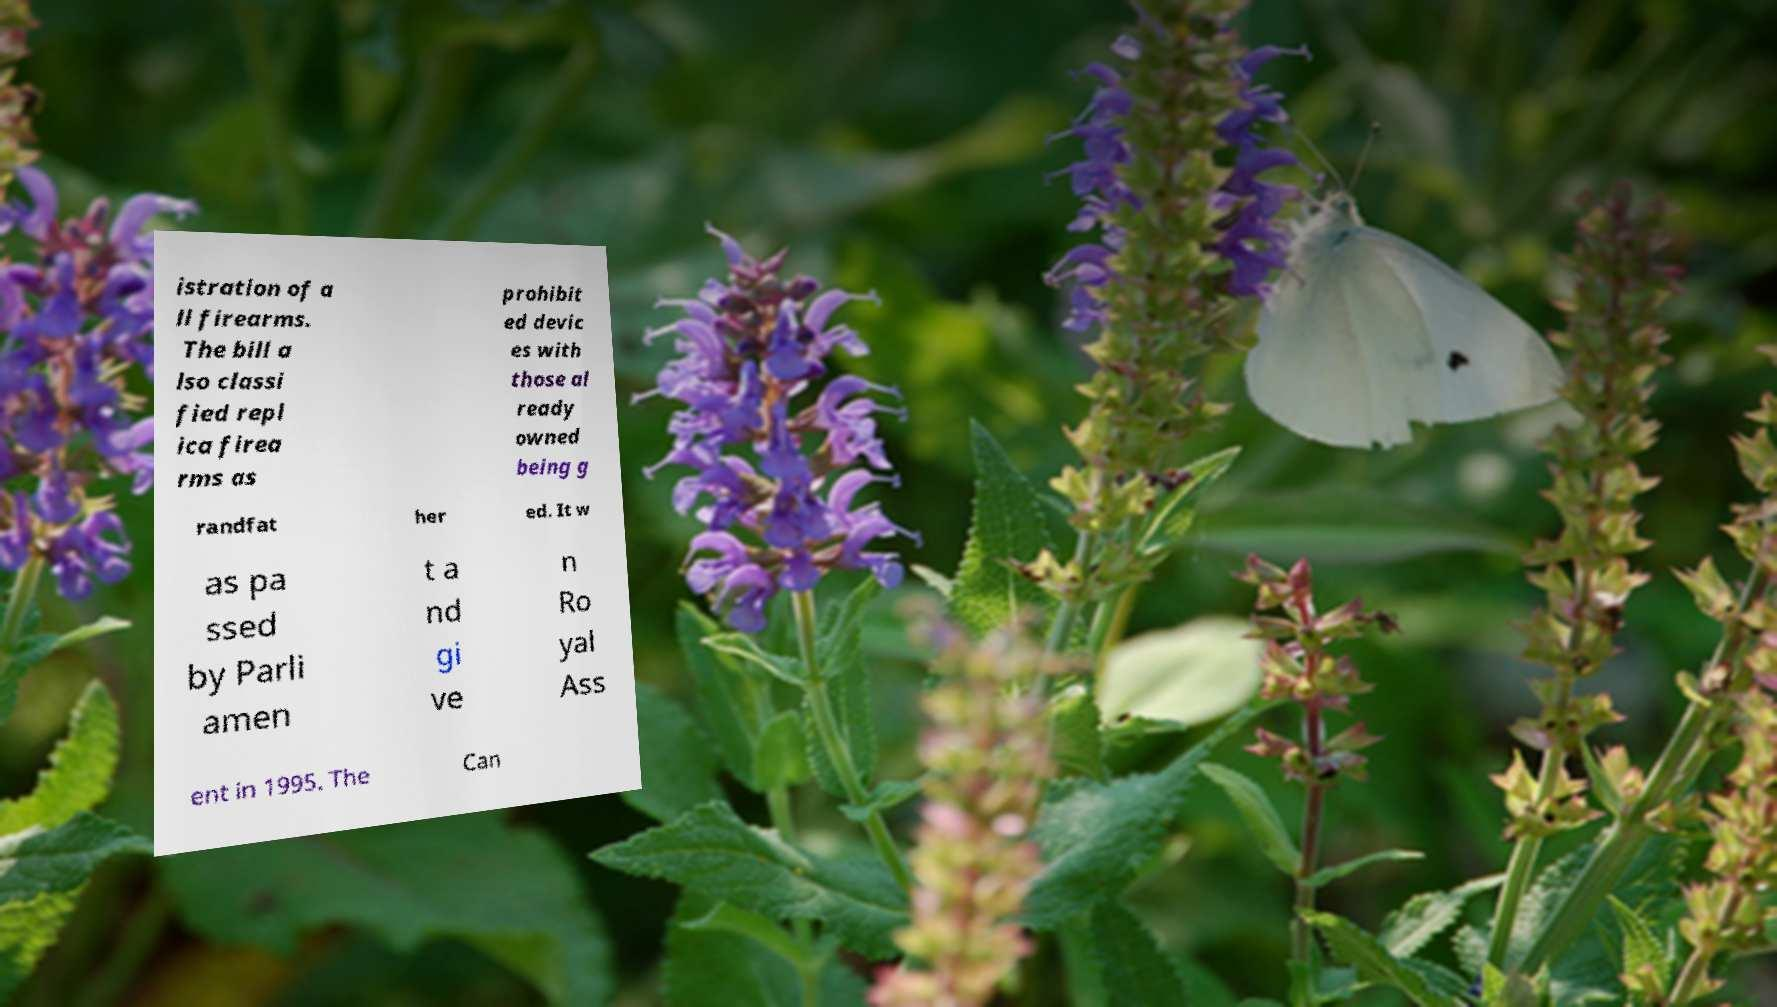Please identify and transcribe the text found in this image. istration of a ll firearms. The bill a lso classi fied repl ica firea rms as prohibit ed devic es with those al ready owned being g randfat her ed. It w as pa ssed by Parli amen t a nd gi ve n Ro yal Ass ent in 1995. The Can 